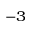<formula> <loc_0><loc_0><loc_500><loc_500>^ { - 3 }</formula> 